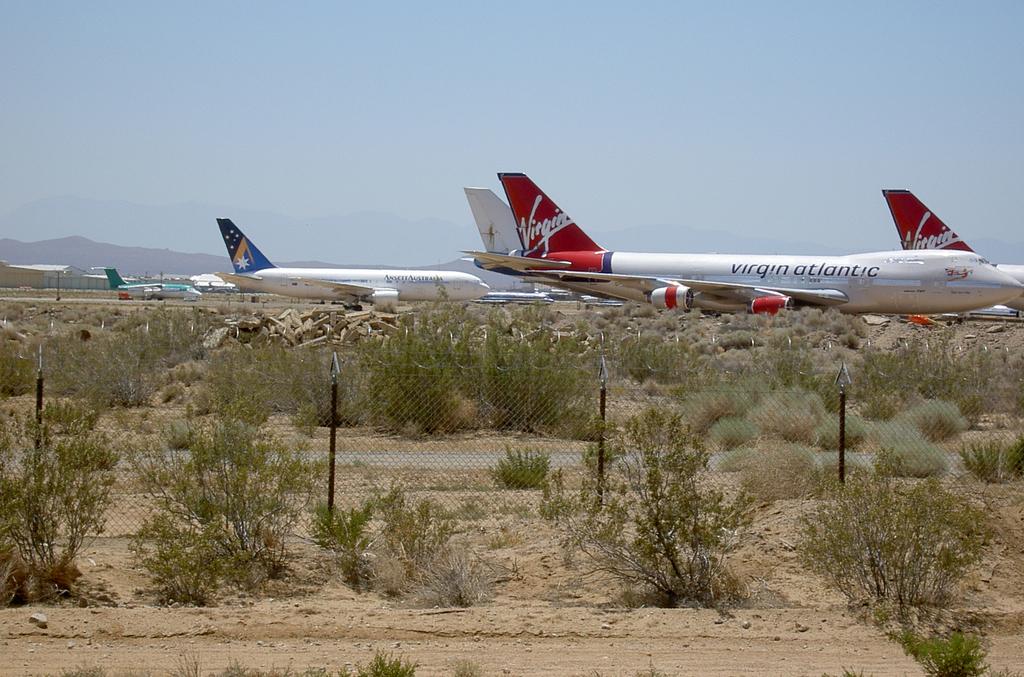What airline does this plane belong to?
Give a very brief answer. Virgin atlantic. 